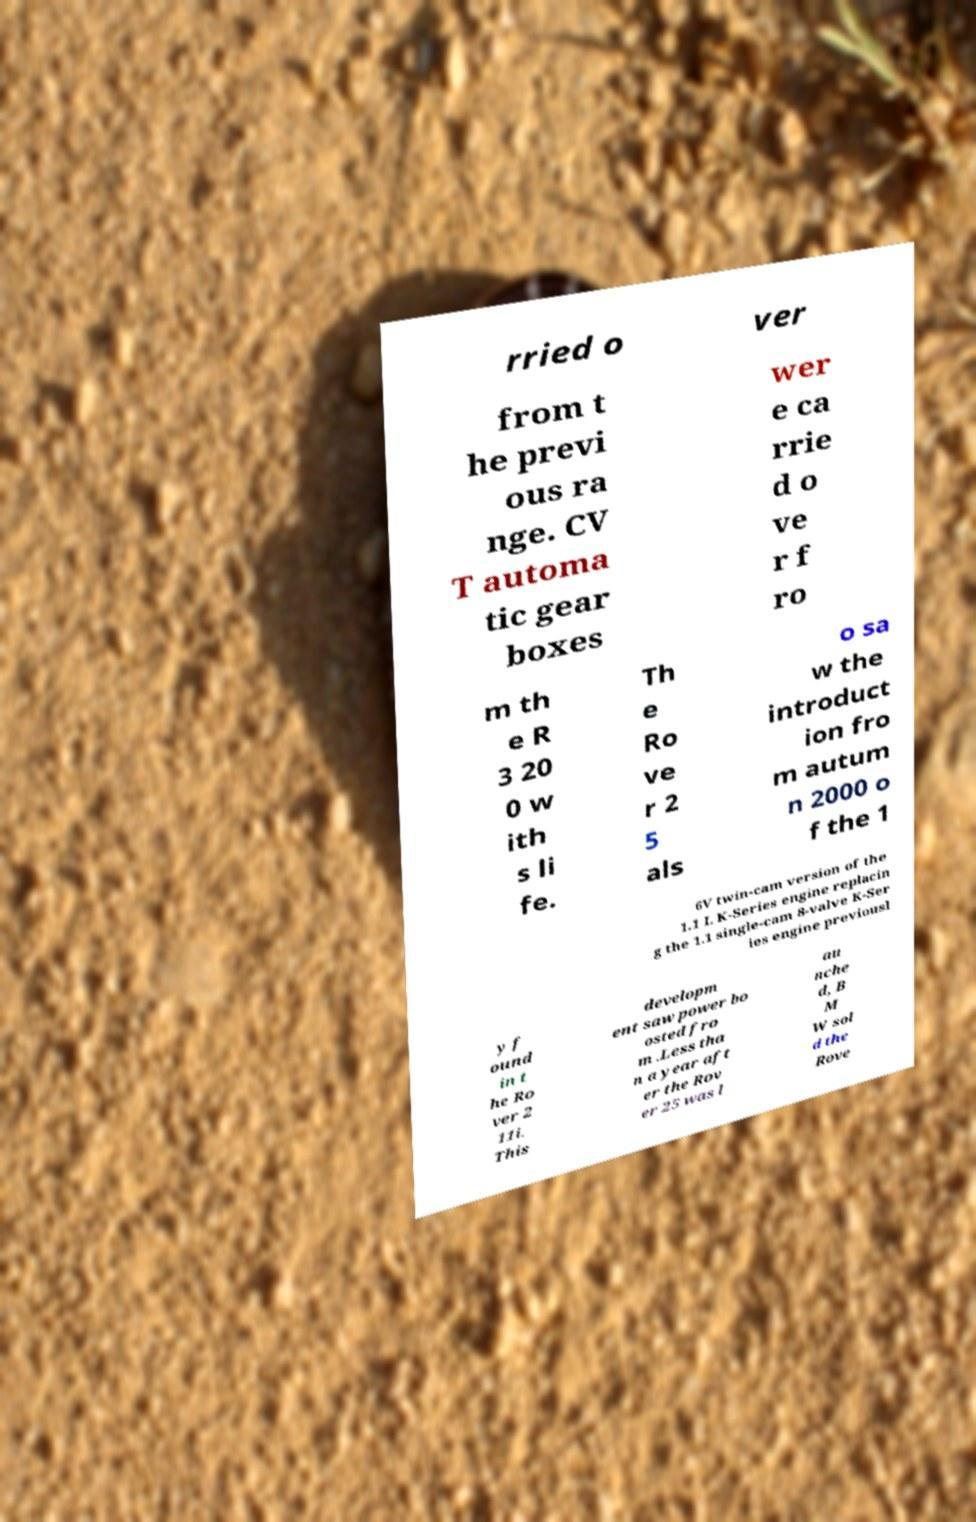There's text embedded in this image that I need extracted. Can you transcribe it verbatim? rried o ver from t he previ ous ra nge. CV T automa tic gear boxes wer e ca rrie d o ve r f ro m th e R 3 20 0 w ith s li fe. Th e Ro ve r 2 5 als o sa w the introduct ion fro m autum n 2000 o f the 1 6V twin-cam version of the 1.1 L K-Series engine replacin g the 1.1 single-cam 8-valve K-Ser ies engine previousl y f ound in t he Ro ver 2 11i. This developm ent saw power bo osted fro m .Less tha n a year aft er the Rov er 25 was l au nche d, B M W sol d the Rove 